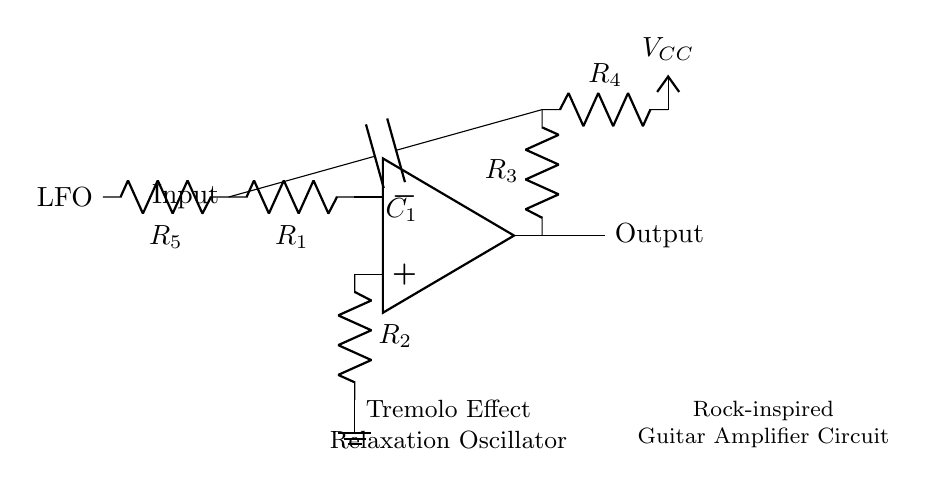What component is used for the timing function in this circuit? The timing function is provided by the capacitor C1, which charges and discharges to create the oscillation necessary for the tremolo effect.
Answer: Capacitor C1 What is the purpose of R1 in the circuit? R1 serves to limit the current flowing into the inverting input of the operational amplifier, which helps set the gain and stability of the circuit.
Answer: Current limiter Which components are connected to the non-inverting input of the op-amp? The non-inverting input is connected to R2, which goes to ground, and also indirectly through R3 and C1 for feedback purposes.
Answer: R2 and feedback How does the circuit produce a tremolo effect? The relaxation oscillator generates a varying output signal due to the charging and discharging of C1, resulting in a modulation of the amplitude of the output signal, creating a tremolo effect.
Answer: Varying output signal What is the role of R4 in the circuit? R4 connects the circuit to the positive supply voltage VCC and influences the charging time of capacitor C1, affecting the oscillation frequency.
Answer: Supply voltage connection What would happen if R5 were removed from the circuit? Removing R5, which introduces the low-frequency oscillation, would eliminate the cycling effect needed to generate the tremolo signal, leading to a loss of the desired modulation.
Answer: Loss of modulation What type of oscillator is depicted in this circuit? This circuit is a relaxation oscillator, which uses the charging and discharging characteristics of a capacitor to produce oscillations.
Answer: Relaxation oscillator 